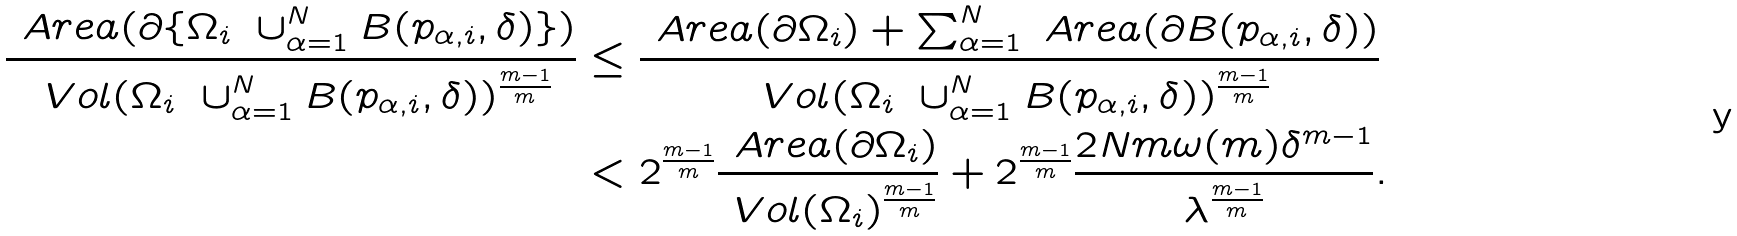<formula> <loc_0><loc_0><loc_500><loc_500>\frac { \ A r e a ( \partial \{ \Omega _ { i } \ \cup _ { \alpha = 1 } ^ { N } B ( p _ { \alpha , i } , \delta ) \} ) } { \ V o l ( \Omega _ { i } \ \cup _ { \alpha = 1 } ^ { N } B ( p _ { \alpha , i } , \delta ) ) ^ { \frac { m - 1 } { m } } } & \leq \frac { \ A r e a ( \partial \Omega _ { i } ) + \sum _ { \alpha = 1 } ^ { N } \ A r e a ( \partial B ( p _ { \alpha , i } , \delta ) ) } { \ V o l ( \Omega _ { i } \ \cup _ { \alpha = 1 } ^ { N } B ( p _ { \alpha , i } , \delta ) ) ^ { \frac { m - 1 } { m } } } \\ & < 2 ^ { \frac { m - 1 } { m } } \frac { \ A r e a ( \partial \Omega _ { i } ) } { \ V o l ( \Omega _ { i } ) ^ { \frac { m - 1 } { m } } } + 2 ^ { \frac { m - 1 } { m } } \frac { 2 N m \omega ( m ) \delta ^ { m - 1 } } { \lambda ^ { \frac { m - 1 } { m } } } .</formula> 